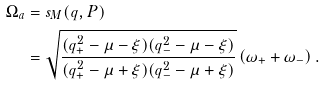Convert formula to latex. <formula><loc_0><loc_0><loc_500><loc_500>\Omega _ { a } & = s _ { M } ( q , P ) \\ & = \sqrt { \frac { ( q _ { + } ^ { 2 } - \mu - \xi ) ( q _ { - } ^ { 2 } - \mu - \xi ) } { ( q _ { + } ^ { 2 } - \mu + \xi ) ( q _ { - } ^ { 2 } - \mu + \xi ) } } \left ( \omega _ { + } + \omega _ { - } \right ) .</formula> 